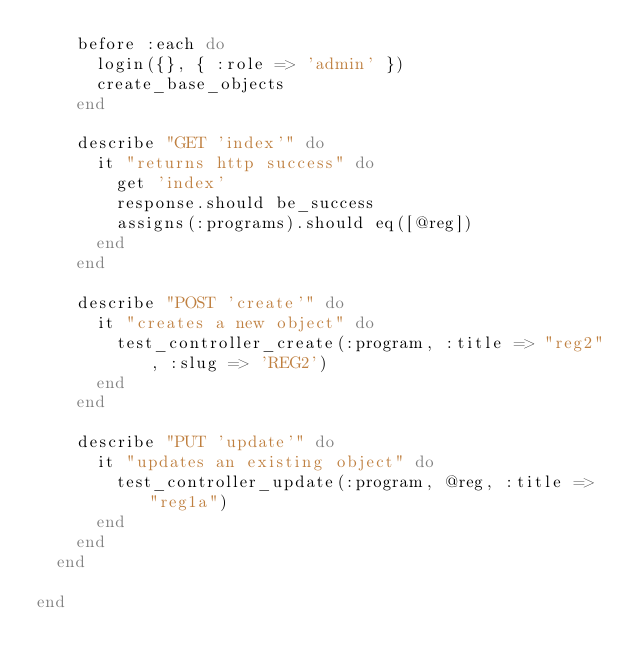Convert code to text. <code><loc_0><loc_0><loc_500><loc_500><_Ruby_>    before :each do
      login({}, { :role => 'admin' })
      create_base_objects
    end

    describe "GET 'index'" do
      it "returns http success" do
        get 'index'
        response.should be_success
        assigns(:programs).should eq([@reg])
      end
    end

    describe "POST 'create'" do
      it "creates a new object" do
        test_controller_create(:program, :title => "reg2", :slug => 'REG2')
      end
    end

    describe "PUT 'update'" do
      it "updates an existing object" do
        test_controller_update(:program, @reg, :title => "reg1a")
      end
    end
  end

end
</code> 